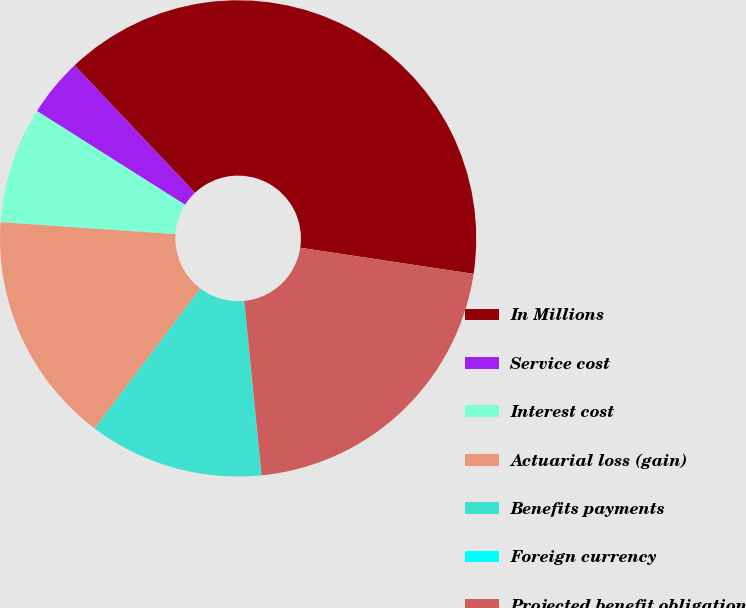<chart> <loc_0><loc_0><loc_500><loc_500><pie_chart><fcel>In Millions<fcel>Service cost<fcel>Interest cost<fcel>Actuarial loss (gain)<fcel>Benefits payments<fcel>Foreign currency<fcel>Projected benefit obligation<nl><fcel>39.44%<fcel>3.96%<fcel>7.9%<fcel>15.79%<fcel>11.84%<fcel>0.02%<fcel>21.05%<nl></chart> 